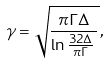Convert formula to latex. <formula><loc_0><loc_0><loc_500><loc_500>\gamma = \sqrt { \frac { \pi \Gamma \Delta } { \ln { \frac { 3 2 \Delta } { \pi \Gamma } \, } } \, } ,</formula> 